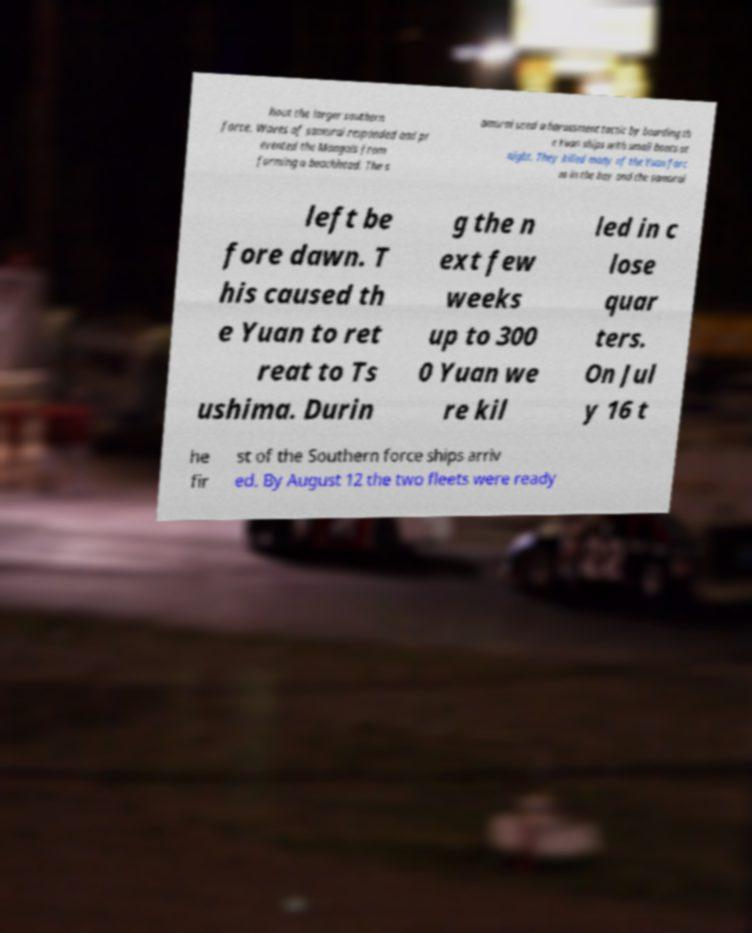Please read and relay the text visible in this image. What does it say? hout the larger southern force. Waves of samurai responded and pr evented the Mongols from forming a beachhead. The s amurai used a harassment tactic by boarding th e Yuan ships with small boats at night. They killed many of the Yuan forc es in the bay and the samurai left be fore dawn. T his caused th e Yuan to ret reat to Ts ushima. Durin g the n ext few weeks up to 300 0 Yuan we re kil led in c lose quar ters. On Jul y 16 t he fir st of the Southern force ships arriv ed. By August 12 the two fleets were ready 